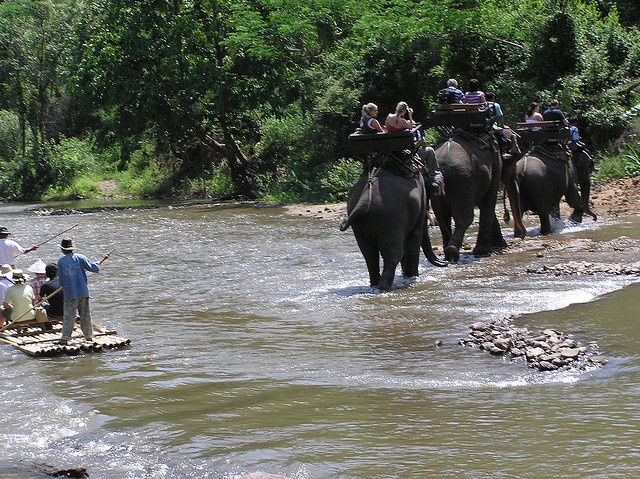Describe the objects in this image and their specific colors. I can see elephant in black, gray, and darkgray tones, elephant in black, gray, and darkgray tones, elephant in black, gray, and darkgray tones, people in black, gray, darkblue, and navy tones, and bench in black, gray, and darkgray tones in this image. 